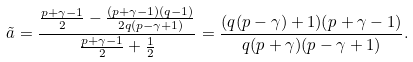<formula> <loc_0><loc_0><loc_500><loc_500>\tilde { a } = \frac { \frac { p + \gamma - 1 } { 2 } - \frac { ( p + \gamma - 1 ) ( q - 1 ) } { 2 q ( p - \gamma + 1 ) } } { \frac { p + \gamma - 1 } { 2 } + \frac { 1 } { 2 } } = \frac { ( q ( p - \gamma ) + 1 ) ( p + \gamma - 1 ) } { q ( p + \gamma ) ( p - \gamma + 1 ) } .</formula> 